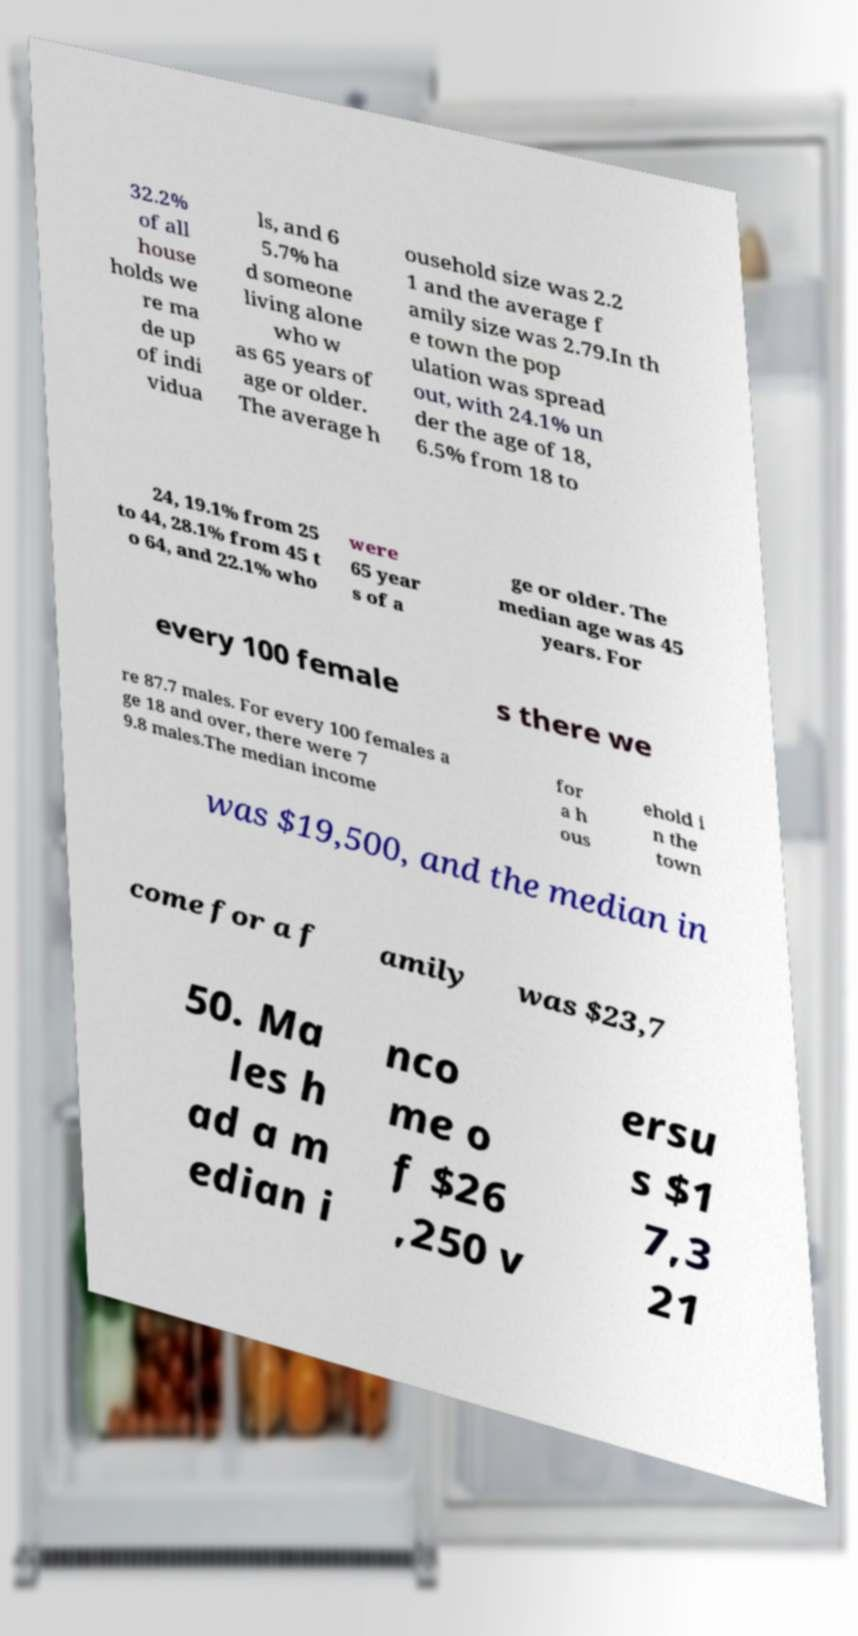Could you extract and type out the text from this image? 32.2% of all house holds we re ma de up of indi vidua ls, and 6 5.7% ha d someone living alone who w as 65 years of age or older. The average h ousehold size was 2.2 1 and the average f amily size was 2.79.In th e town the pop ulation was spread out, with 24.1% un der the age of 18, 6.5% from 18 to 24, 19.1% from 25 to 44, 28.1% from 45 t o 64, and 22.1% who were 65 year s of a ge or older. The median age was 45 years. For every 100 female s there we re 87.7 males. For every 100 females a ge 18 and over, there were 7 9.8 males.The median income for a h ous ehold i n the town was $19,500, and the median in come for a f amily was $23,7 50. Ma les h ad a m edian i nco me o f $26 ,250 v ersu s $1 7,3 21 